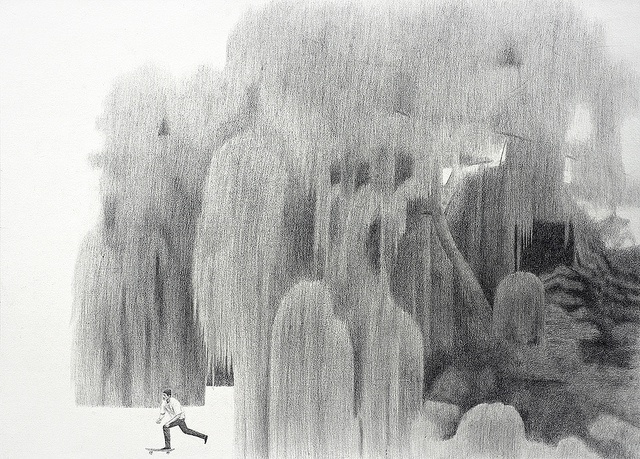Describe the objects in this image and their specific colors. I can see people in white, lightgray, gray, darkgray, and black tones and skateboard in white, darkgray, lightgray, and gray tones in this image. 